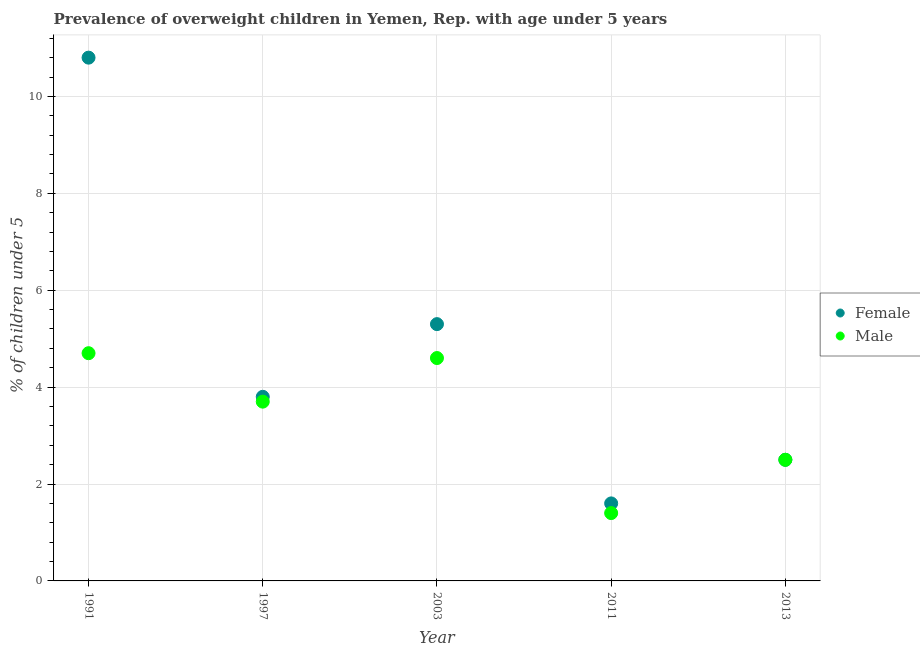How many different coloured dotlines are there?
Your answer should be compact. 2. Is the number of dotlines equal to the number of legend labels?
Provide a succinct answer. Yes. What is the percentage of obese male children in 2003?
Ensure brevity in your answer.  4.6. Across all years, what is the maximum percentage of obese female children?
Your answer should be very brief. 10.8. Across all years, what is the minimum percentage of obese male children?
Offer a terse response. 1.4. In which year was the percentage of obese male children maximum?
Your answer should be very brief. 1991. What is the total percentage of obese male children in the graph?
Provide a short and direct response. 16.9. What is the difference between the percentage of obese female children in 2003 and that in 2011?
Ensure brevity in your answer.  3.7. What is the difference between the percentage of obese female children in 1997 and the percentage of obese male children in 1991?
Offer a very short reply. -0.9. What is the average percentage of obese male children per year?
Give a very brief answer. 3.38. In the year 2003, what is the difference between the percentage of obese female children and percentage of obese male children?
Offer a very short reply. 0.7. In how many years, is the percentage of obese male children greater than 5.2 %?
Your answer should be very brief. 0. What is the ratio of the percentage of obese female children in 2003 to that in 2013?
Offer a terse response. 2.12. Is the percentage of obese male children in 2003 less than that in 2013?
Offer a very short reply. No. Is the difference between the percentage of obese male children in 1991 and 2013 greater than the difference between the percentage of obese female children in 1991 and 2013?
Provide a short and direct response. No. What is the difference between the highest and the second highest percentage of obese female children?
Your answer should be very brief. 5.5. What is the difference between the highest and the lowest percentage of obese female children?
Keep it short and to the point. 9.2. Is the sum of the percentage of obese female children in 1991 and 2013 greater than the maximum percentage of obese male children across all years?
Your answer should be very brief. Yes. Does the percentage of obese male children monotonically increase over the years?
Provide a succinct answer. No. Is the percentage of obese female children strictly greater than the percentage of obese male children over the years?
Your answer should be very brief. No. Are the values on the major ticks of Y-axis written in scientific E-notation?
Your response must be concise. No. Does the graph contain any zero values?
Provide a short and direct response. No. Does the graph contain grids?
Provide a succinct answer. Yes. Where does the legend appear in the graph?
Your answer should be compact. Center right. How many legend labels are there?
Keep it short and to the point. 2. What is the title of the graph?
Keep it short and to the point. Prevalence of overweight children in Yemen, Rep. with age under 5 years. What is the label or title of the X-axis?
Offer a terse response. Year. What is the label or title of the Y-axis?
Give a very brief answer.  % of children under 5. What is the  % of children under 5 in Female in 1991?
Your answer should be compact. 10.8. What is the  % of children under 5 in Male in 1991?
Provide a short and direct response. 4.7. What is the  % of children under 5 in Female in 1997?
Ensure brevity in your answer.  3.8. What is the  % of children under 5 in Male in 1997?
Ensure brevity in your answer.  3.7. What is the  % of children under 5 in Female in 2003?
Your answer should be very brief. 5.3. What is the  % of children under 5 of Male in 2003?
Offer a terse response. 4.6. What is the  % of children under 5 in Female in 2011?
Ensure brevity in your answer.  1.6. What is the  % of children under 5 of Male in 2011?
Provide a succinct answer. 1.4. What is the  % of children under 5 in Male in 2013?
Offer a terse response. 2.5. Across all years, what is the maximum  % of children under 5 in Female?
Your response must be concise. 10.8. Across all years, what is the maximum  % of children under 5 of Male?
Make the answer very short. 4.7. Across all years, what is the minimum  % of children under 5 in Female?
Your answer should be very brief. 1.6. Across all years, what is the minimum  % of children under 5 in Male?
Provide a succinct answer. 1.4. What is the total  % of children under 5 in Female in the graph?
Your answer should be compact. 24. What is the total  % of children under 5 of Male in the graph?
Your answer should be very brief. 16.9. What is the difference between the  % of children under 5 of Female in 1991 and that in 2003?
Make the answer very short. 5.5. What is the difference between the  % of children under 5 in Female in 1997 and that in 2003?
Your answer should be compact. -1.5. What is the difference between the  % of children under 5 in Male in 1997 and that in 2003?
Keep it short and to the point. -0.9. What is the difference between the  % of children under 5 of Female in 1997 and that in 2011?
Ensure brevity in your answer.  2.2. What is the difference between the  % of children under 5 in Male in 1997 and that in 2011?
Give a very brief answer. 2.3. What is the difference between the  % of children under 5 in Male in 1997 and that in 2013?
Your answer should be very brief. 1.2. What is the difference between the  % of children under 5 of Female in 2011 and that in 2013?
Give a very brief answer. -0.9. What is the difference between the  % of children under 5 in Female in 1991 and the  % of children under 5 in Male in 1997?
Provide a succinct answer. 7.1. What is the difference between the  % of children under 5 in Female in 1991 and the  % of children under 5 in Male in 2003?
Keep it short and to the point. 6.2. What is the difference between the  % of children under 5 of Female in 1997 and the  % of children under 5 of Male in 2003?
Give a very brief answer. -0.8. What is the difference between the  % of children under 5 of Female in 1997 and the  % of children under 5 of Male in 2011?
Keep it short and to the point. 2.4. What is the difference between the  % of children under 5 of Female in 1997 and the  % of children under 5 of Male in 2013?
Offer a very short reply. 1.3. What is the difference between the  % of children under 5 of Female in 2003 and the  % of children under 5 of Male in 2011?
Your answer should be very brief. 3.9. What is the difference between the  % of children under 5 of Female in 2011 and the  % of children under 5 of Male in 2013?
Offer a terse response. -0.9. What is the average  % of children under 5 of Female per year?
Offer a terse response. 4.8. What is the average  % of children under 5 of Male per year?
Your answer should be very brief. 3.38. In the year 1997, what is the difference between the  % of children under 5 of Female and  % of children under 5 of Male?
Give a very brief answer. 0.1. In the year 2003, what is the difference between the  % of children under 5 of Female and  % of children under 5 of Male?
Your answer should be very brief. 0.7. In the year 2011, what is the difference between the  % of children under 5 of Female and  % of children under 5 of Male?
Your response must be concise. 0.2. In the year 2013, what is the difference between the  % of children under 5 of Female and  % of children under 5 of Male?
Your answer should be compact. 0. What is the ratio of the  % of children under 5 in Female in 1991 to that in 1997?
Provide a succinct answer. 2.84. What is the ratio of the  % of children under 5 in Male in 1991 to that in 1997?
Your answer should be compact. 1.27. What is the ratio of the  % of children under 5 in Female in 1991 to that in 2003?
Make the answer very short. 2.04. What is the ratio of the  % of children under 5 in Male in 1991 to that in 2003?
Provide a succinct answer. 1.02. What is the ratio of the  % of children under 5 of Female in 1991 to that in 2011?
Your answer should be compact. 6.75. What is the ratio of the  % of children under 5 of Male in 1991 to that in 2011?
Make the answer very short. 3.36. What is the ratio of the  % of children under 5 in Female in 1991 to that in 2013?
Keep it short and to the point. 4.32. What is the ratio of the  % of children under 5 in Male in 1991 to that in 2013?
Your response must be concise. 1.88. What is the ratio of the  % of children under 5 in Female in 1997 to that in 2003?
Offer a terse response. 0.72. What is the ratio of the  % of children under 5 in Male in 1997 to that in 2003?
Your response must be concise. 0.8. What is the ratio of the  % of children under 5 in Female in 1997 to that in 2011?
Your response must be concise. 2.38. What is the ratio of the  % of children under 5 in Male in 1997 to that in 2011?
Your answer should be very brief. 2.64. What is the ratio of the  % of children under 5 in Female in 1997 to that in 2013?
Keep it short and to the point. 1.52. What is the ratio of the  % of children under 5 of Male in 1997 to that in 2013?
Provide a short and direct response. 1.48. What is the ratio of the  % of children under 5 of Female in 2003 to that in 2011?
Your answer should be compact. 3.31. What is the ratio of the  % of children under 5 of Male in 2003 to that in 2011?
Give a very brief answer. 3.29. What is the ratio of the  % of children under 5 of Female in 2003 to that in 2013?
Your answer should be compact. 2.12. What is the ratio of the  % of children under 5 in Male in 2003 to that in 2013?
Make the answer very short. 1.84. What is the ratio of the  % of children under 5 of Female in 2011 to that in 2013?
Your answer should be compact. 0.64. What is the ratio of the  % of children under 5 of Male in 2011 to that in 2013?
Offer a very short reply. 0.56. What is the difference between the highest and the lowest  % of children under 5 in Female?
Keep it short and to the point. 9.2. What is the difference between the highest and the lowest  % of children under 5 in Male?
Provide a short and direct response. 3.3. 